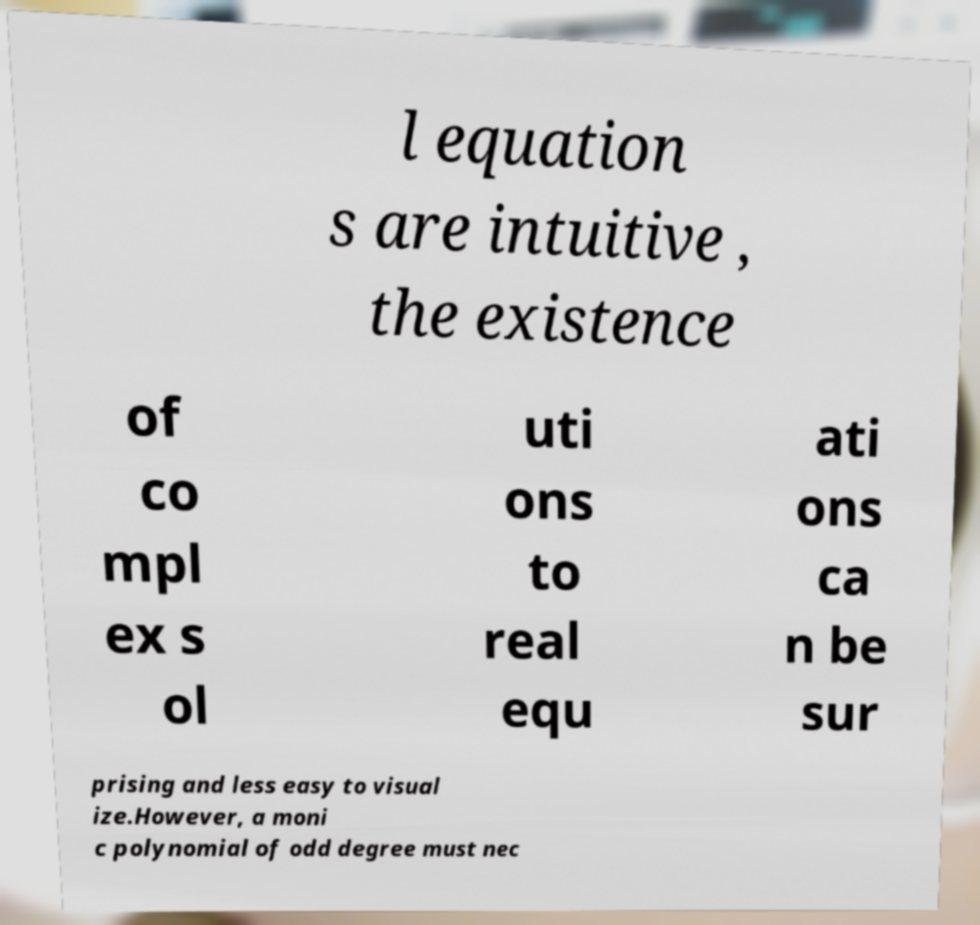Can you accurately transcribe the text from the provided image for me? l equation s are intuitive , the existence of co mpl ex s ol uti ons to real equ ati ons ca n be sur prising and less easy to visual ize.However, a moni c polynomial of odd degree must nec 